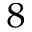<formula> <loc_0><loc_0><loc_500><loc_500>^ { 8 }</formula> 